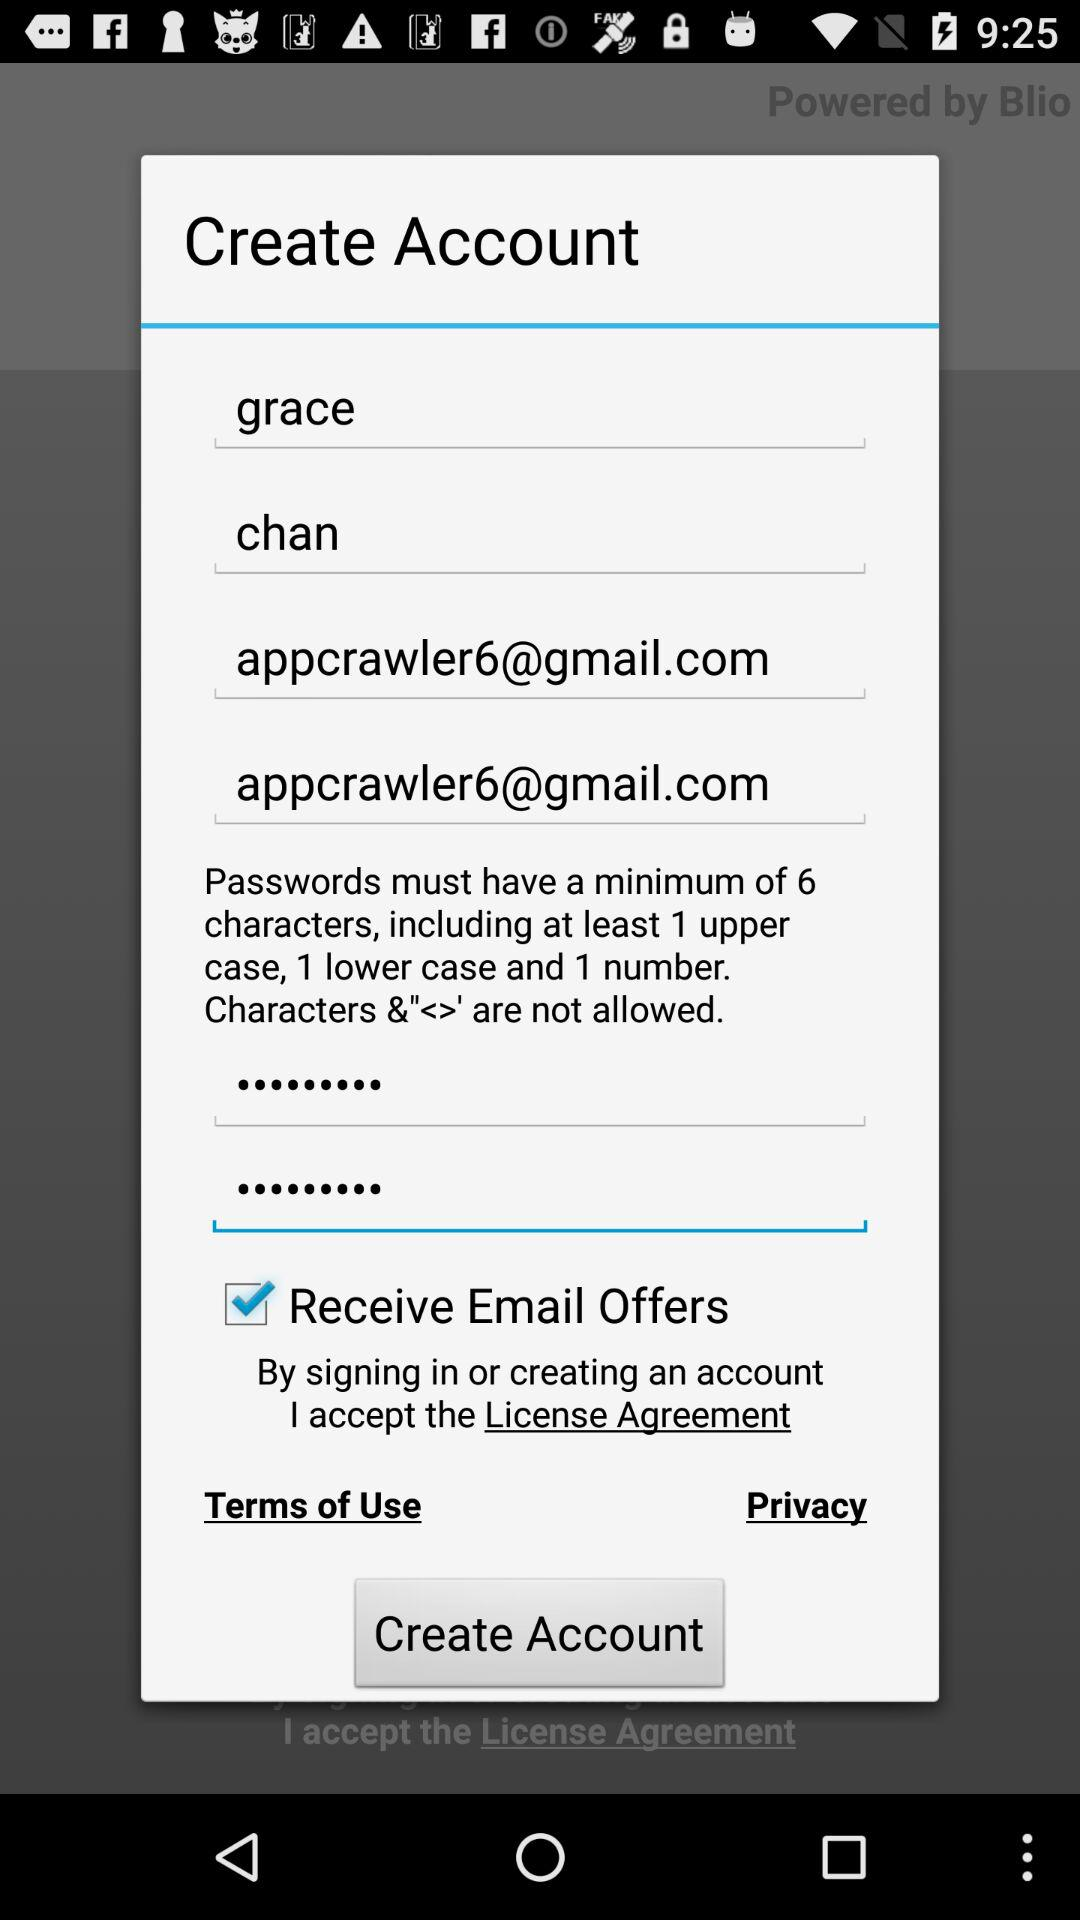What is the minimum number of characters required for the password? The minimum number of characters required for the password is 6. 